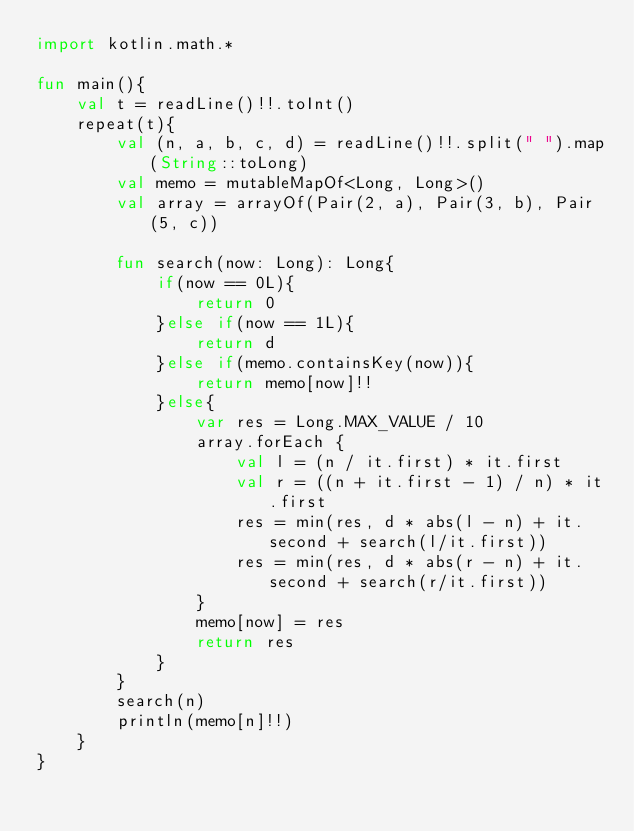<code> <loc_0><loc_0><loc_500><loc_500><_Kotlin_>import kotlin.math.*

fun main(){
    val t = readLine()!!.toInt()
    repeat(t){
        val (n, a, b, c, d) = readLine()!!.split(" ").map(String::toLong)
        val memo = mutableMapOf<Long, Long>()
        val array = arrayOf(Pair(2, a), Pair(3, b), Pair(5, c))

        fun search(now: Long): Long{
            if(now == 0L){
                return 0
            }else if(now == 1L){
                return d
            }else if(memo.containsKey(now)){
                return memo[now]!!
            }else{
                var res = Long.MAX_VALUE / 10
                array.forEach {
                    val l = (n / it.first) * it.first
                    val r = ((n + it.first - 1) / n) * it.first
                    res = min(res, d * abs(l - n) + it.second + search(l/it.first))
                    res = min(res, d * abs(r - n) + it.second + search(r/it.first))
                }
                memo[now] = res
                return res
            }
        }
        search(n)
        println(memo[n]!!)
    }
}</code> 